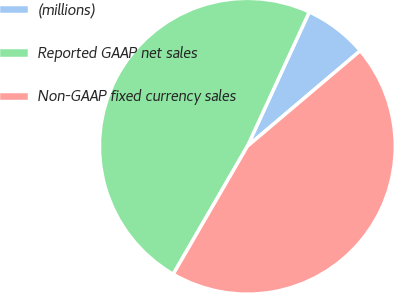Convert chart to OTSL. <chart><loc_0><loc_0><loc_500><loc_500><pie_chart><fcel>(millions)<fcel>Reported GAAP net sales<fcel>Non-GAAP fixed currency sales<nl><fcel>6.95%<fcel>48.51%<fcel>44.54%<nl></chart> 